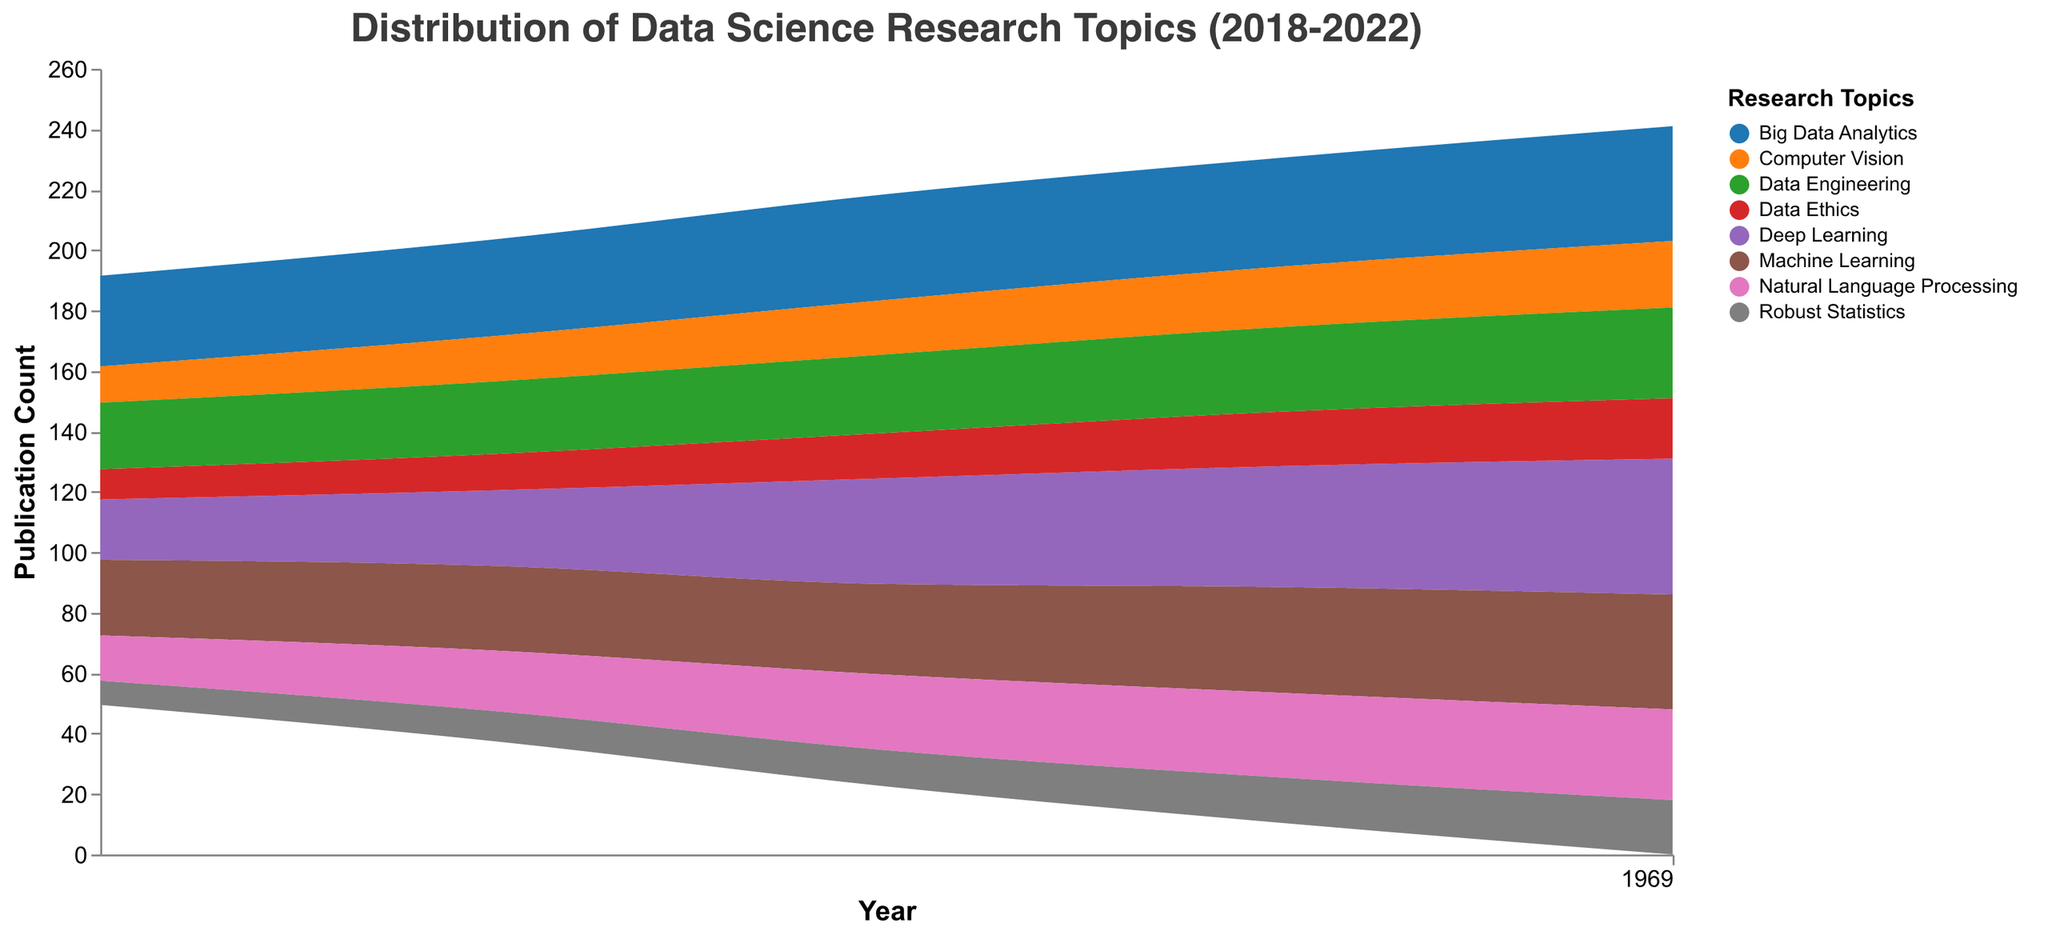What is the main title of the figure? The main title is explicitly stated at the top of the figure. It provides a concise summary of what the figure represents.
Answer: Distribution of Data Science Research Topics (2018-2022) How many research topics are represented in the figure? To find the number of research topics, count distinct color areas or refer to the legend, which lists all the separate topics.
Answer: 8 Which research topic had the highest number of publications in 2022? Look at the topmost layer of the stack plot for 2022. The largest area represents the topic with the highest publication count.
Answer: Big Data Analytics How did the publication count for Deep Learning evolve from 2018 to 2022? Identify the area corresponding to Deep Learning and track its changes across the years 2018 to 2022, noting the general trend.
Answer: Increased Which research topic shows the least increase in publication count over the years? Compare the areas of all research topics from 2018 to 2022. The least increase will be the narrowest difference in area proportional to the initial size in 2018.
Answer: Robust Statistics What is the combined publication count for Machine Learning and Computer Vision in 2020? Locate Machine Learning and Computer Vision's spots in 2020. Sum the publication counts for both these topics.
Answer: 48 Which year had the highest overall publication count across all topics? Compare the summed height of all topic areas (stacked areas) for each year. The tallest stack indicates the maximum overall publication count.
Answer: 2022 What is the visual difference between Data Ethics and Data Engineering in 2021? Compare the colored area sizes for Data Ethics and Data Engineering due to their representation in stacked form in 2021.
Answer: Data Engineering is larger than Data Ethics Between 2020 and 2021, which topic saw a higher increase: Natural Language Processing or Deep Learning? Look at both Natural Language Processing and Deep Learning areas in 2020 and 2021. Calculate the difference for both and compare.
Answer: Deep Learning In 2019, which research topic was the third most published? In 2019, review the areas from the top. The third layer corresponds to the third most published topic.
Answer: Natural Language Processing 